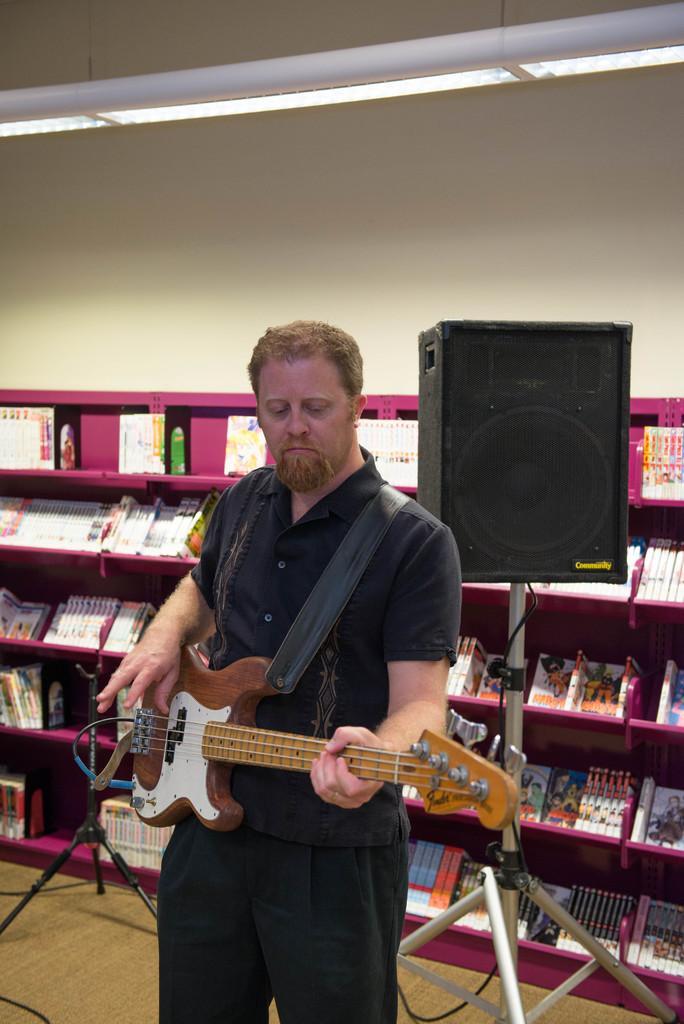Can you describe this image briefly? This man holds guitar. Sound box with stand. This is rack with things and books. 